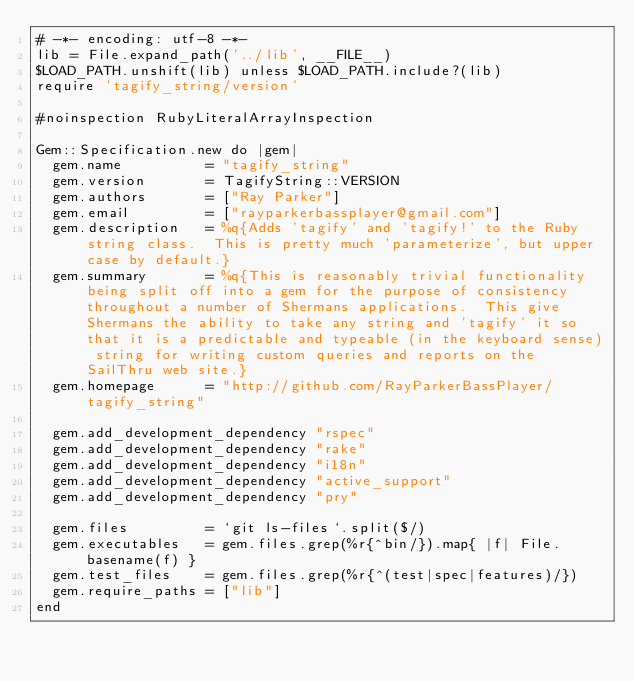<code> <loc_0><loc_0><loc_500><loc_500><_Ruby_># -*- encoding: utf-8 -*-
lib = File.expand_path('../lib', __FILE__)
$LOAD_PATH.unshift(lib) unless $LOAD_PATH.include?(lib)
require 'tagify_string/version'

#noinspection RubyLiteralArrayInspection

Gem::Specification.new do |gem|
  gem.name          = "tagify_string"
  gem.version       = TagifyString::VERSION
  gem.authors       = ["Ray Parker"]
  gem.email         = ["rayparkerbassplayer@gmail.com"]
  gem.description   = %q{Adds 'tagify' and 'tagify!' to the Ruby string class.  This is pretty much 'parameterize', but upper case by default.}
  gem.summary       = %q{This is reasonably trivial functionality being split off into a gem for the purpose of consistency throughout a number of Shermans applications.  This give Shermans the ability to take any string and 'tagify' it so that it is a predictable and typeable (in the keyboard sense) string for writing custom queries and reports on the SailThru web site.}
  gem.homepage      = "http://github.com/RayParkerBassPlayer/tagify_string"

  gem.add_development_dependency "rspec"
  gem.add_development_dependency "rake"
  gem.add_development_dependency "i18n"
  gem.add_development_dependency "active_support"
  gem.add_development_dependency "pry"

  gem.files         = `git ls-files`.split($/)
  gem.executables   = gem.files.grep(%r{^bin/}).map{ |f| File.basename(f) }
  gem.test_files    = gem.files.grep(%r{^(test|spec|features)/})
  gem.require_paths = ["lib"]
end
</code> 